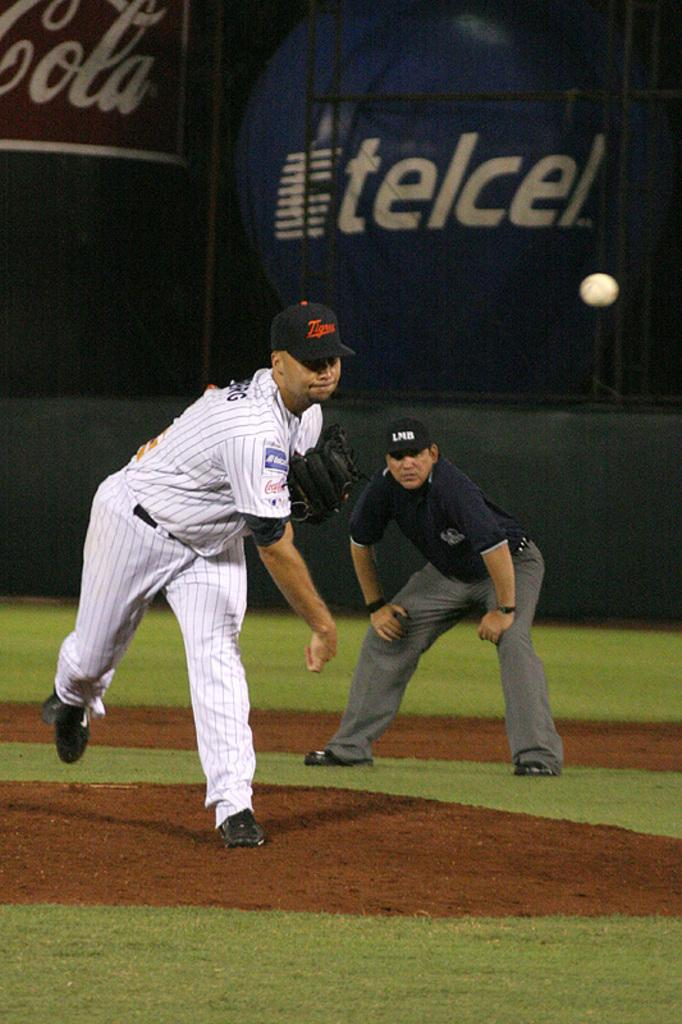Provide a one-sentence caption for the provided image. A baseball player throws a pitch while an add for TelCel plays behind him. 